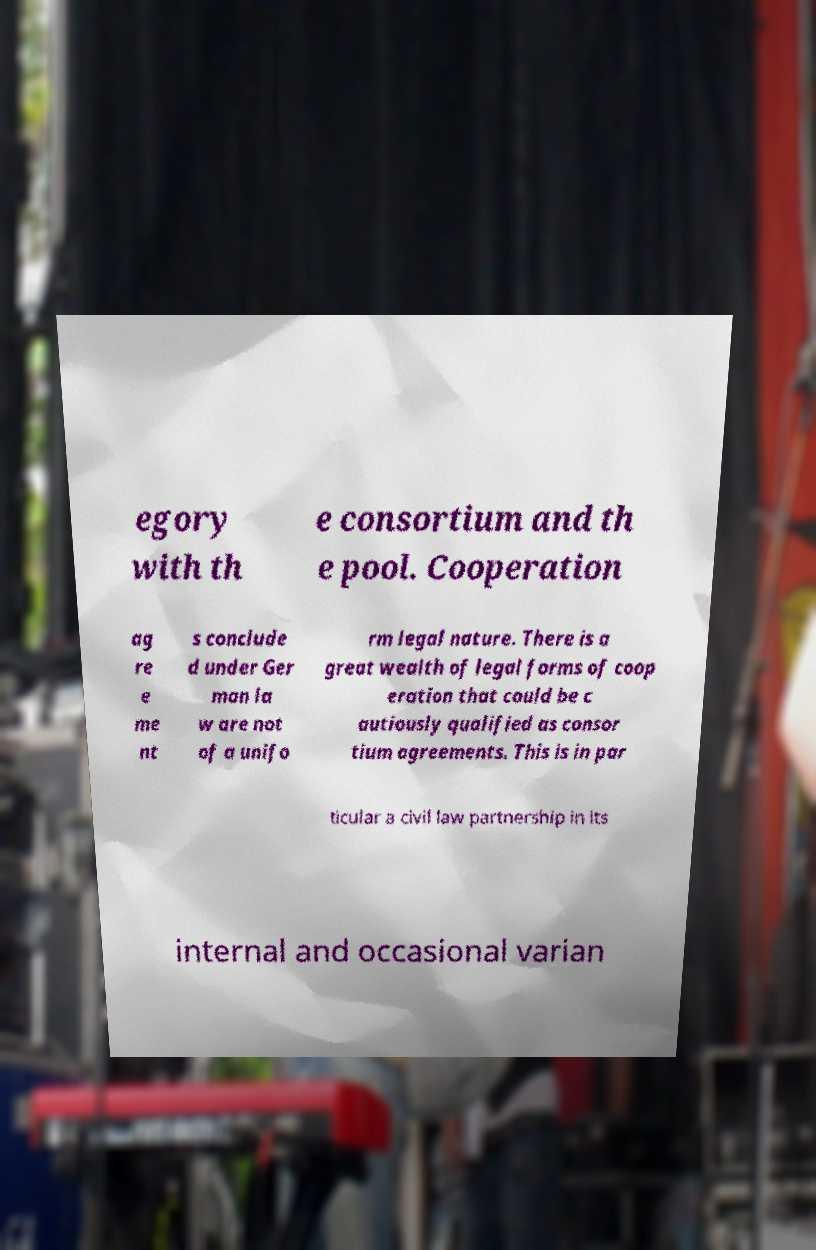Please read and relay the text visible in this image. What does it say? egory with th e consortium and th e pool. Cooperation ag re e me nt s conclude d under Ger man la w are not of a unifo rm legal nature. There is a great wealth of legal forms of coop eration that could be c autiously qualified as consor tium agreements. This is in par ticular a civil law partnership in its internal and occasional varian 